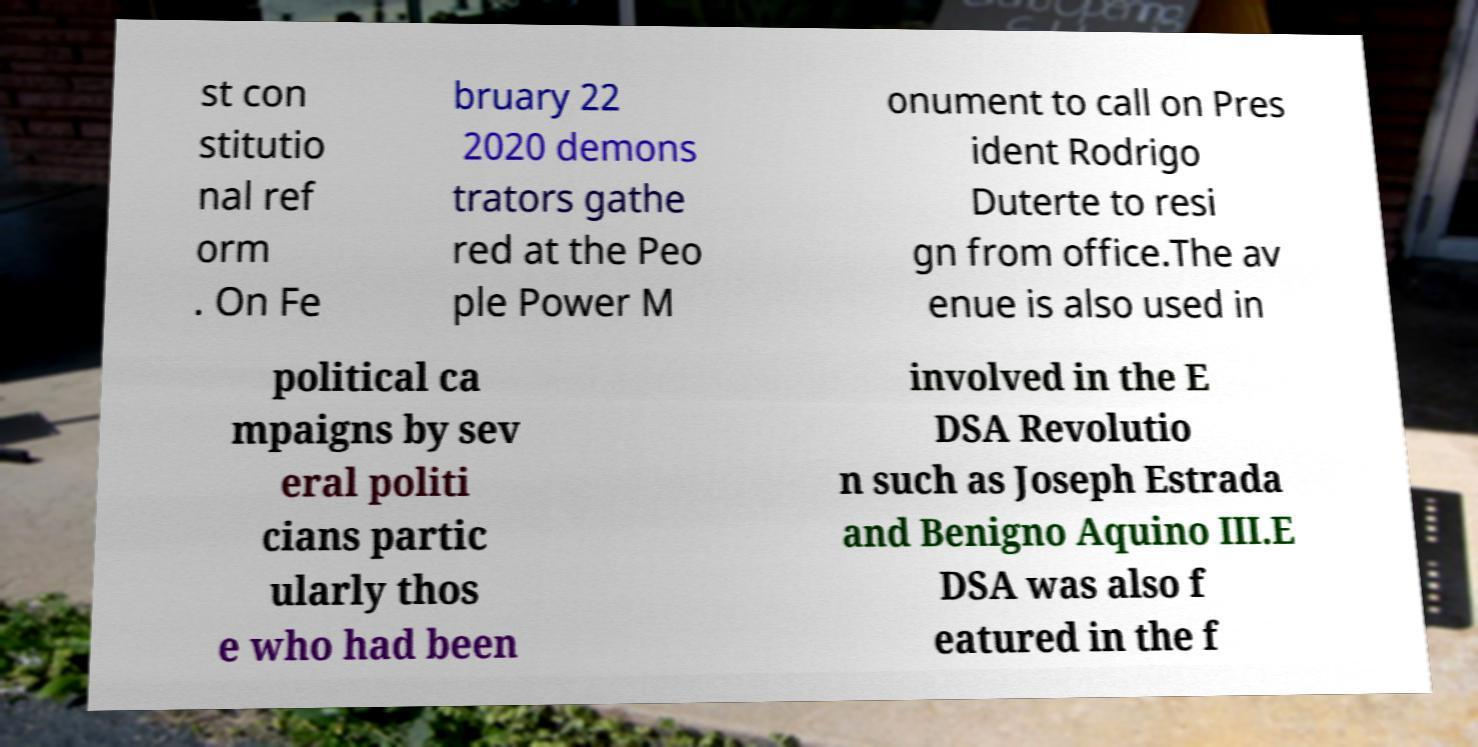Please identify and transcribe the text found in this image. st con stitutio nal ref orm . On Fe bruary 22 2020 demons trators gathe red at the Peo ple Power M onument to call on Pres ident Rodrigo Duterte to resi gn from office.The av enue is also used in political ca mpaigns by sev eral politi cians partic ularly thos e who had been involved in the E DSA Revolutio n such as Joseph Estrada and Benigno Aquino III.E DSA was also f eatured in the f 